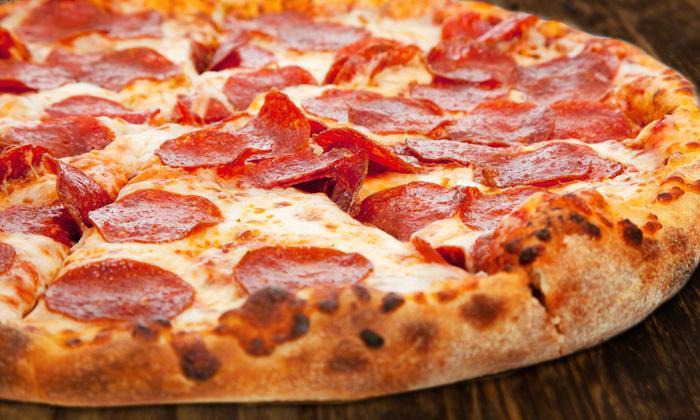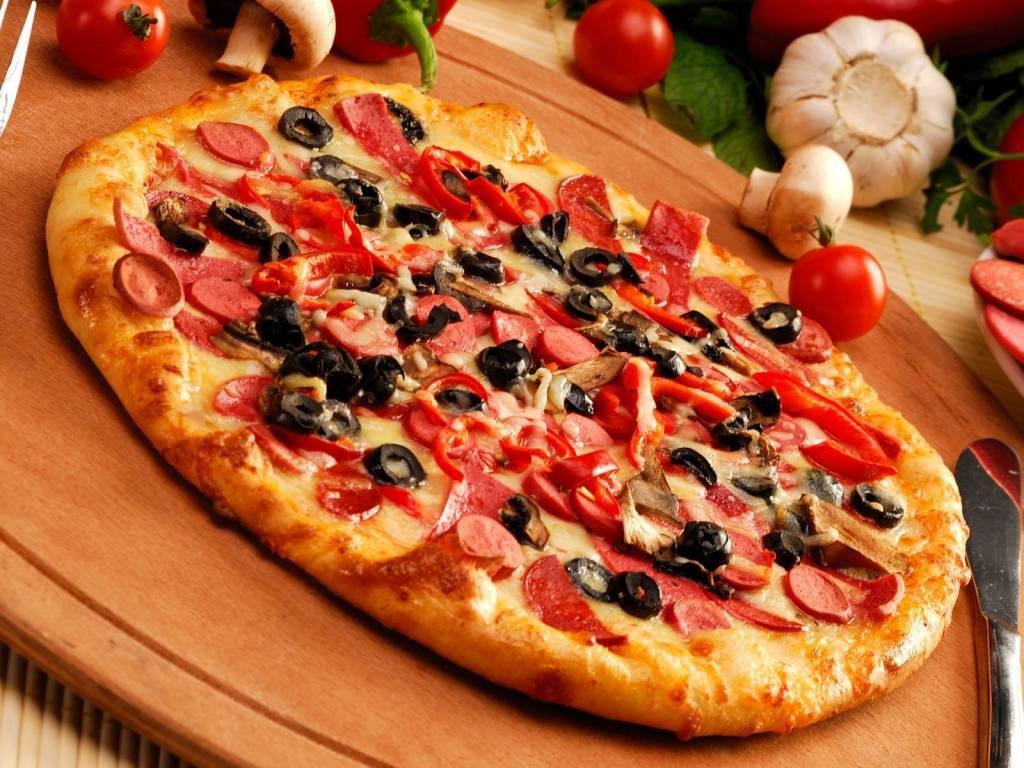The first image is the image on the left, the second image is the image on the right. Analyze the images presented: Is the assertion "One image features a single round pizza that is not cut into slices, and the other image features one pepperoni pizza cut into wedge-shaped slices." valid? Answer yes or no. Yes. The first image is the image on the left, the second image is the image on the right. Evaluate the accuracy of this statement regarding the images: "One of the pizzas has onion on it.". Is it true? Answer yes or no. No. 